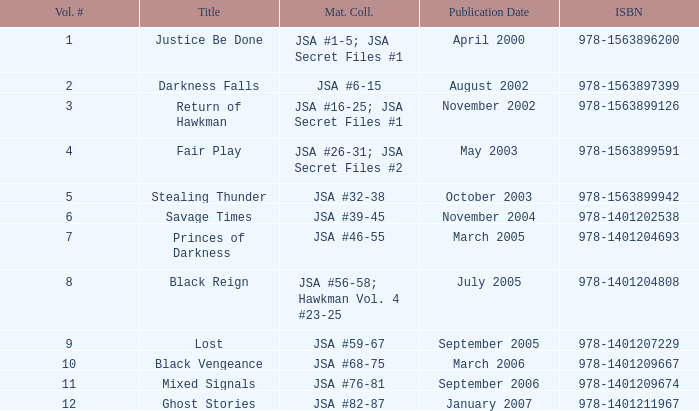What is the count of volume numbers for the title darkness falls? 2.0. 